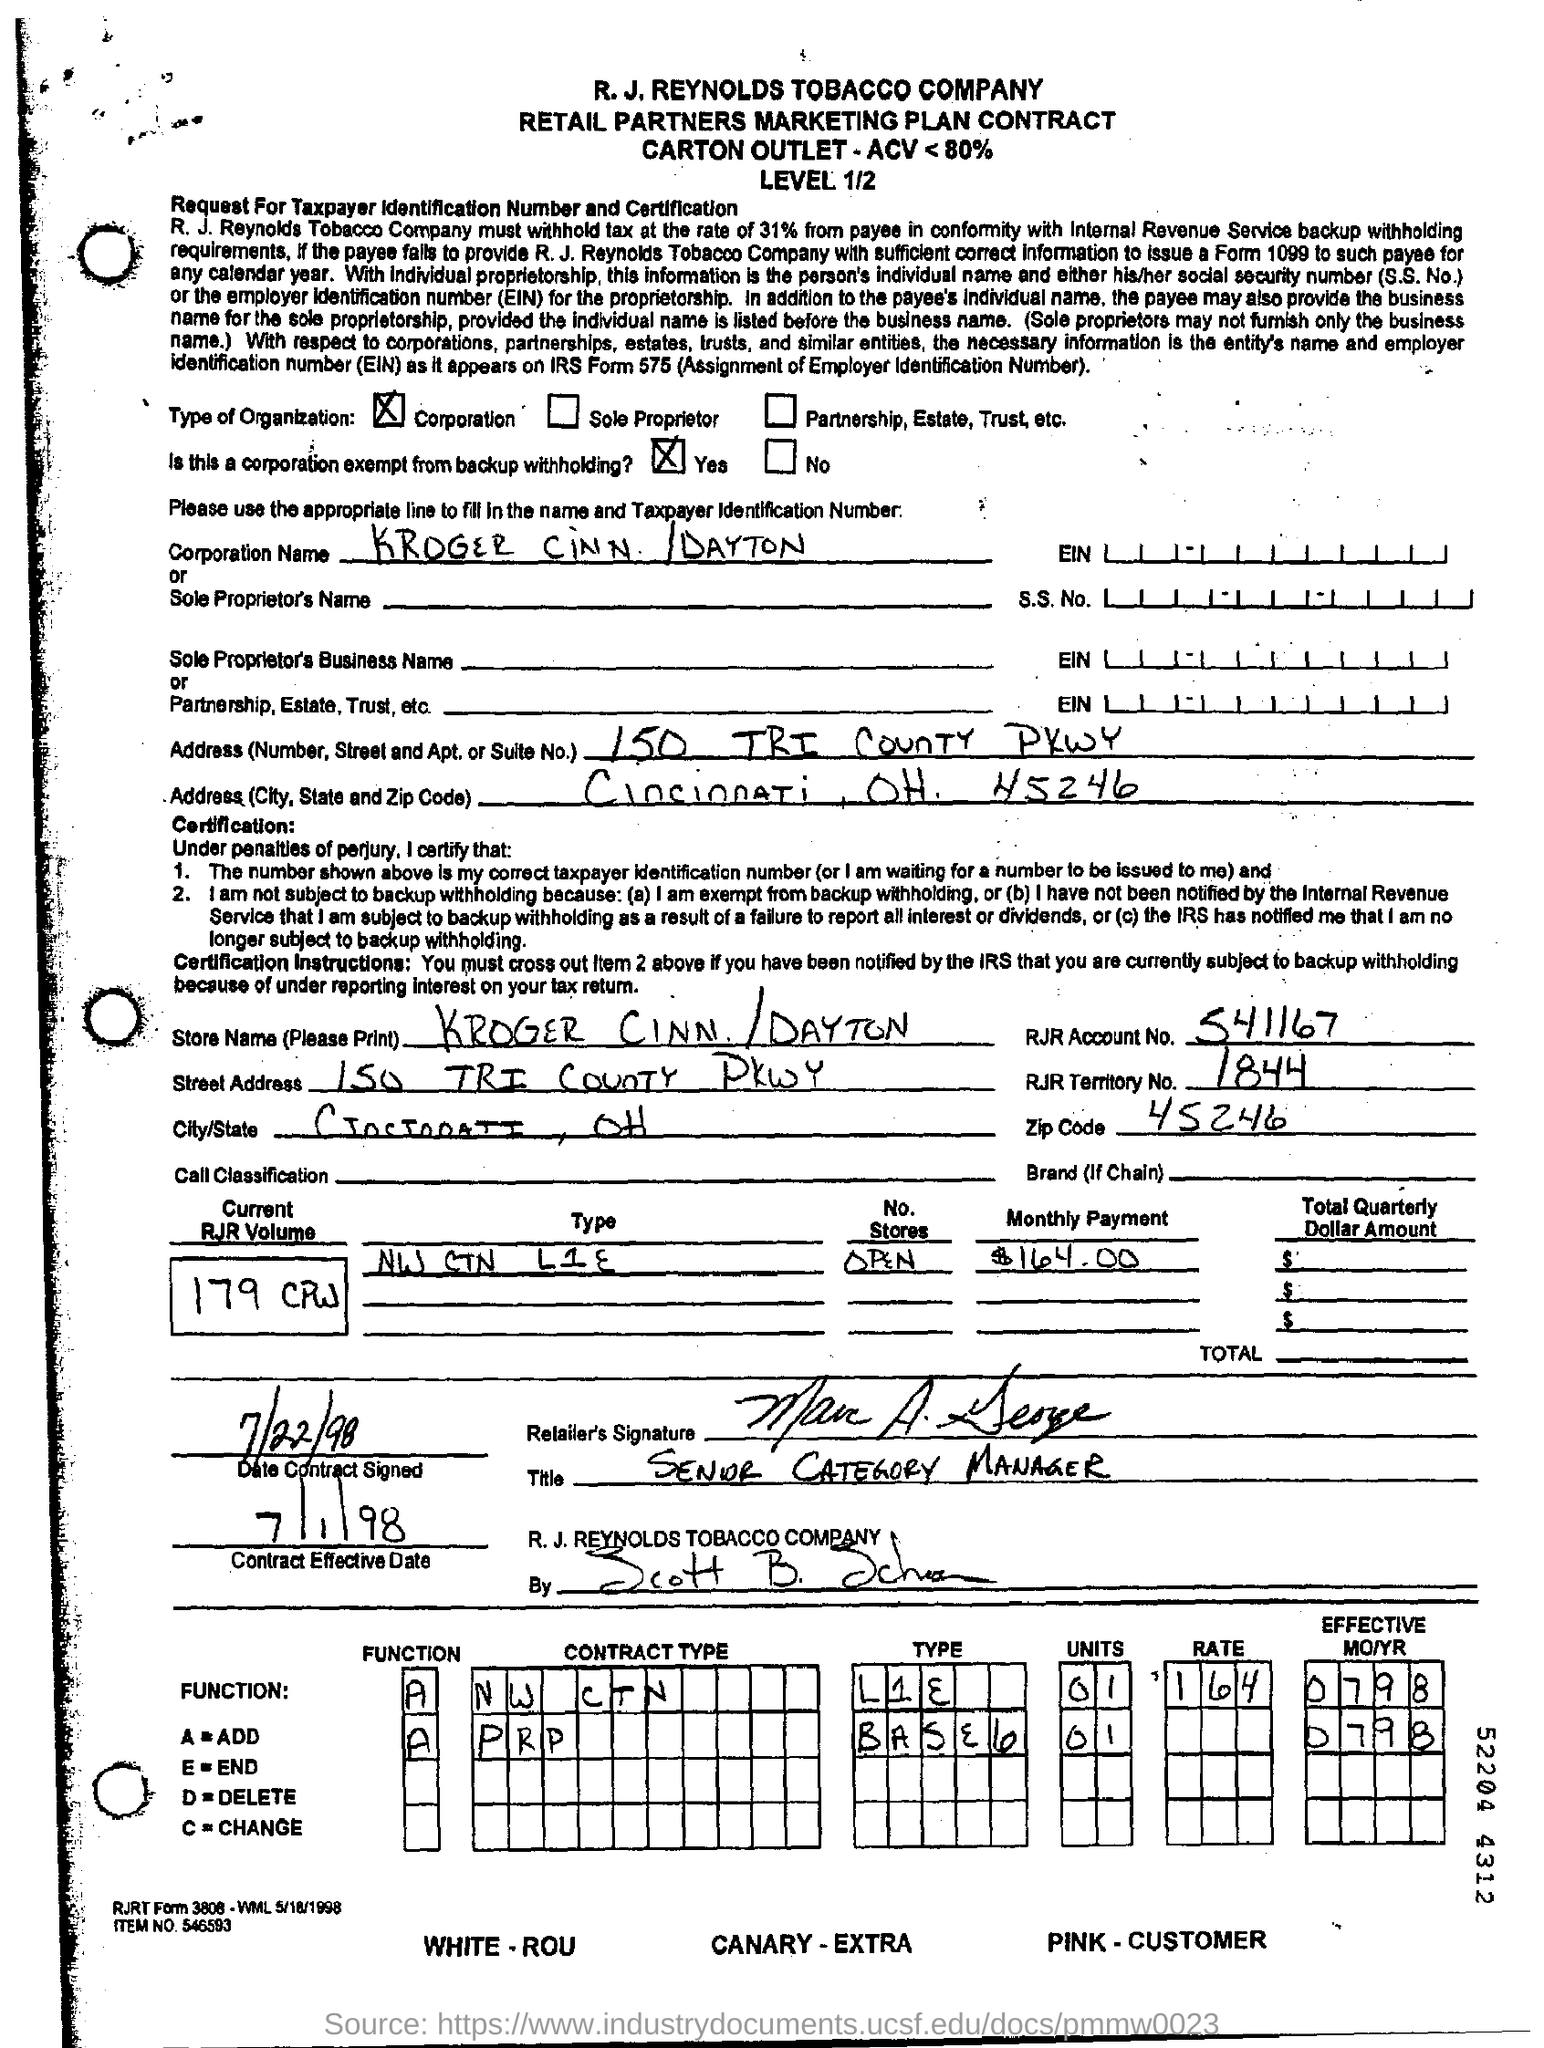Mention the type of organization ?
Keep it short and to the point. Corporation. Is this a corporation exempt from backup withholding ?
Give a very brief answer. Yes. What is the rjr territory no.?
Your answer should be compact. 1844. How much is the monthly payment ?
Your answer should be compact. $164.00. Mention the contract effective date ?
Your answer should be very brief. 7/1/98. What is the function a=?
Your response must be concise. Add. What is the function d=?
Your answer should be compact. Delete. What is the item no. ?
Provide a short and direct response. 546593. 